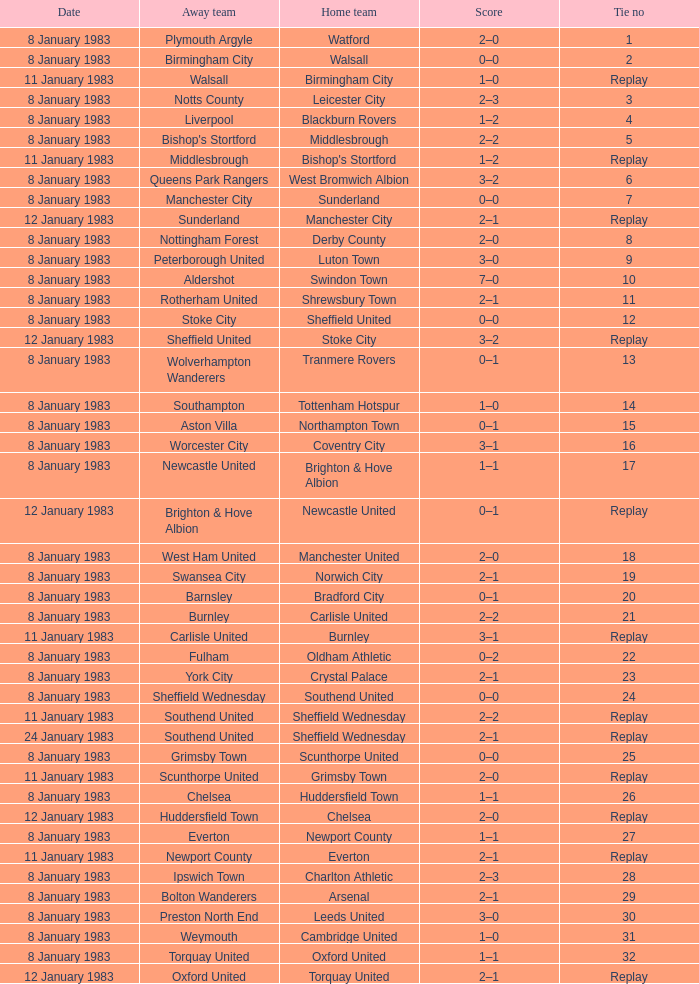On what date was Tie #13 played? 8 January 1983. 